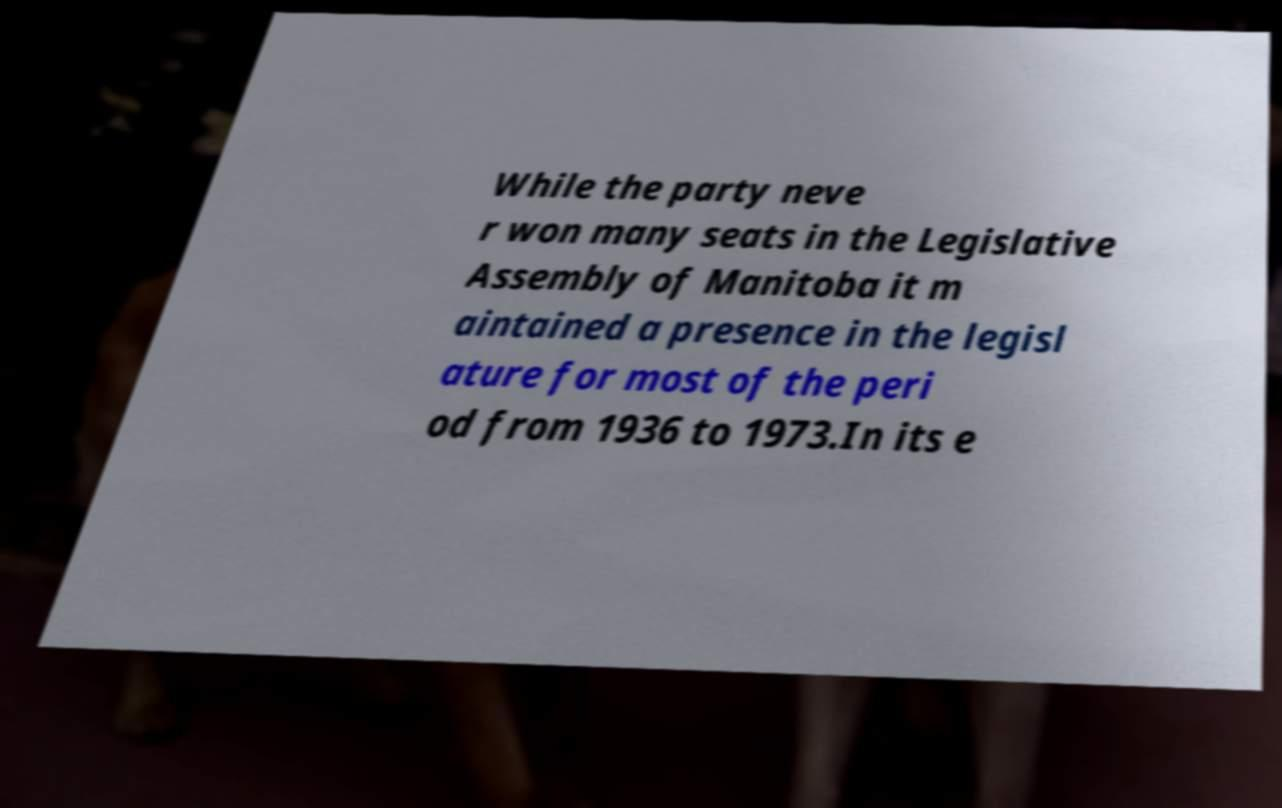I need the written content from this picture converted into text. Can you do that? While the party neve r won many seats in the Legislative Assembly of Manitoba it m aintained a presence in the legisl ature for most of the peri od from 1936 to 1973.In its e 